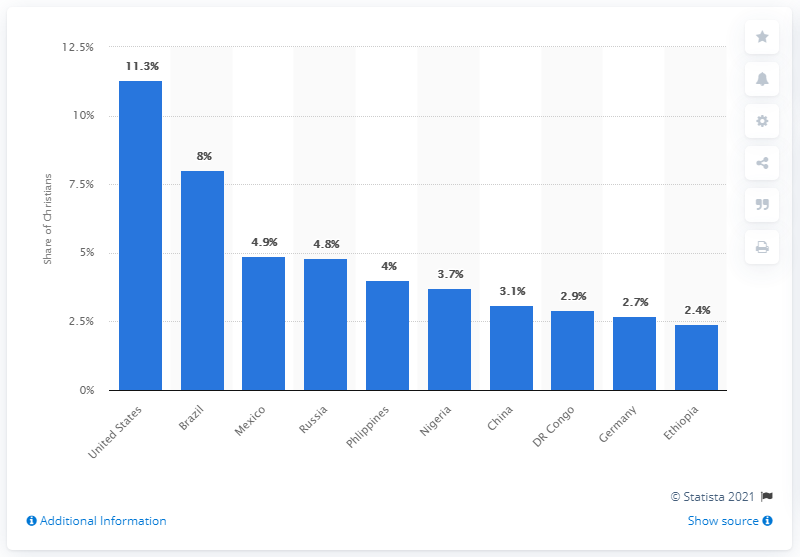Give some essential details in this illustration. In 2010, approximately 11.3% of all Christians worldwide lived in the United States. 